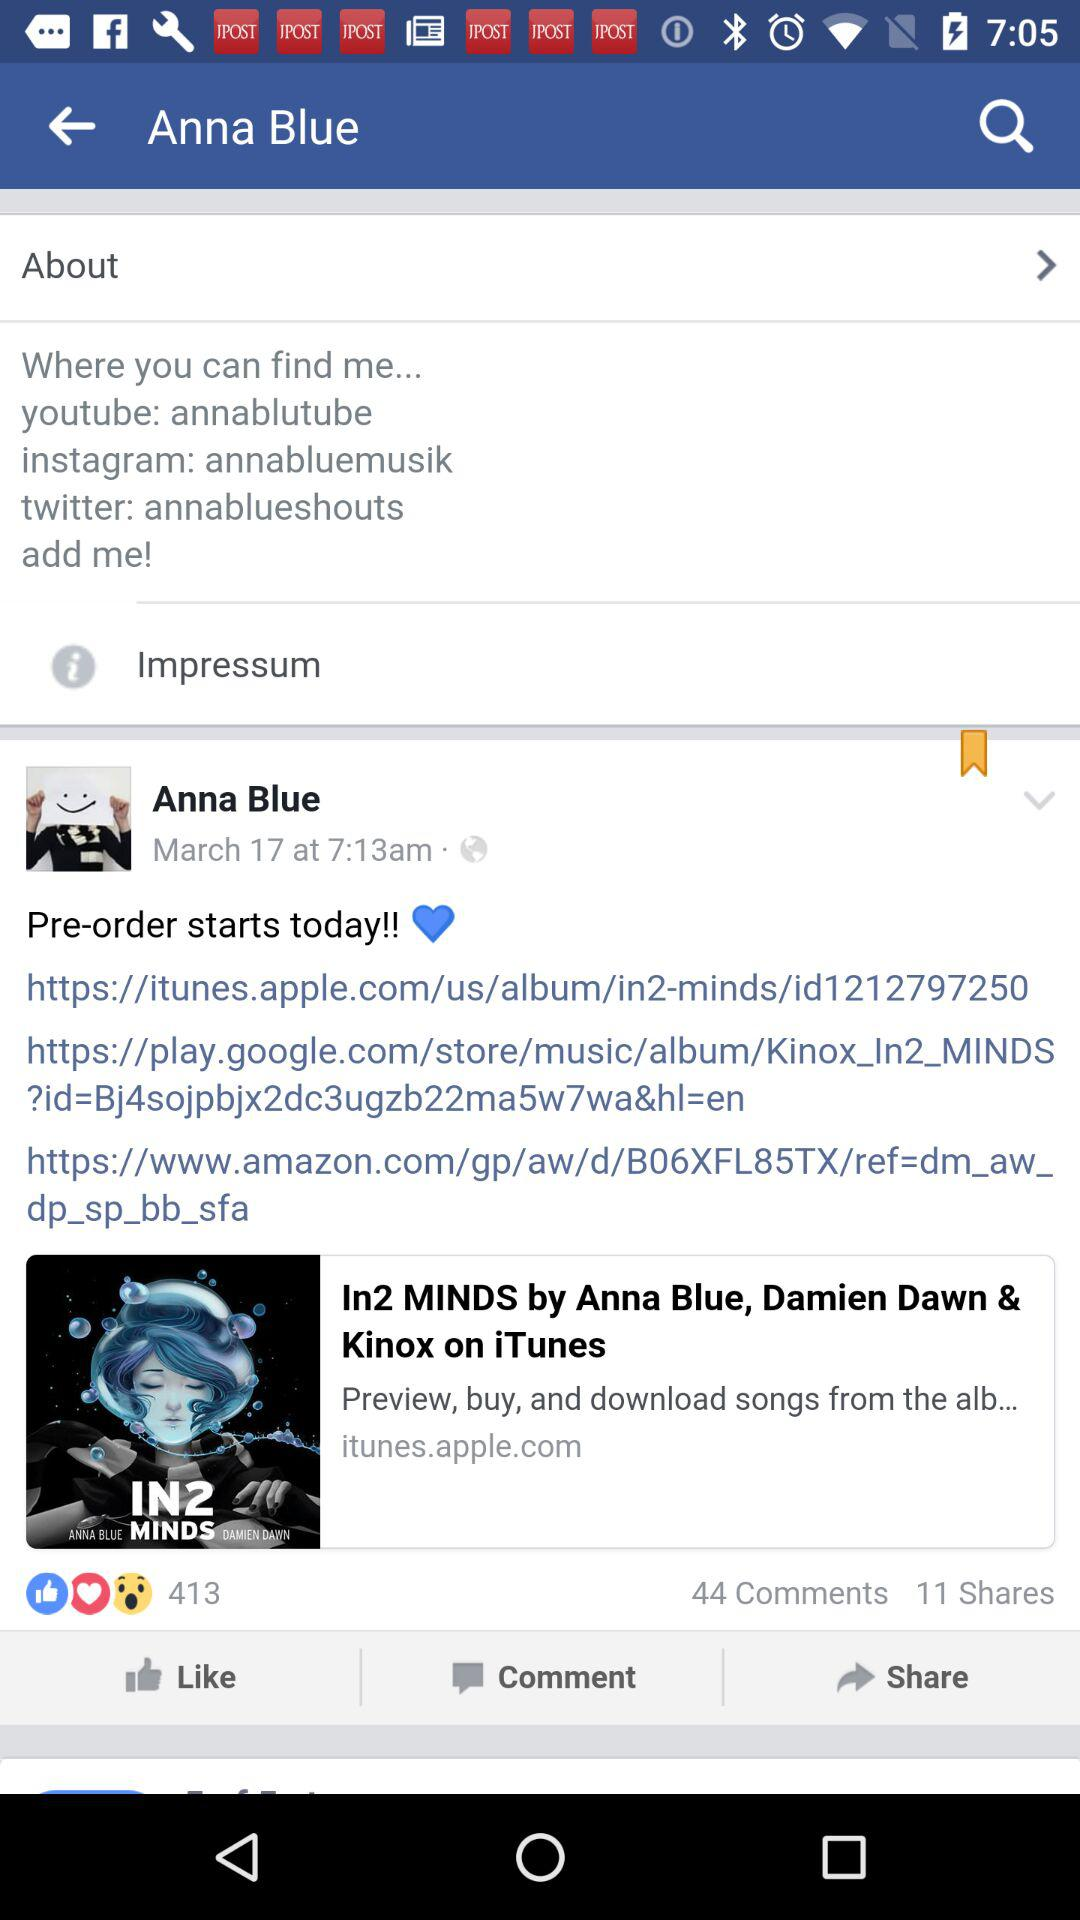When was the post posted? The post was posted on March 17 at 7:13 a.m. 